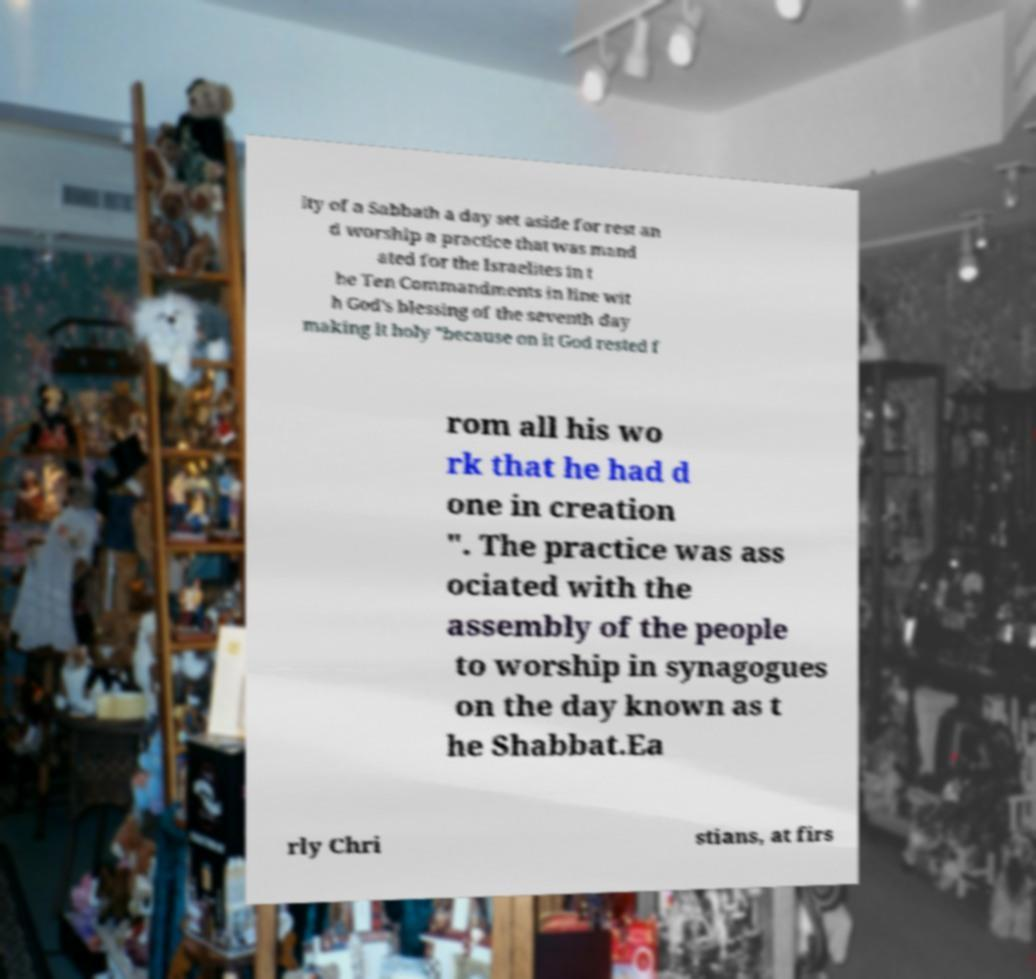I need the written content from this picture converted into text. Can you do that? ity of a Sabbath a day set aside for rest an d worship a practice that was mand ated for the Israelites in t he Ten Commandments in line wit h God's blessing of the seventh day making it holy "because on it God rested f rom all his wo rk that he had d one in creation ". The practice was ass ociated with the assembly of the people to worship in synagogues on the day known as t he Shabbat.Ea rly Chri stians, at firs 